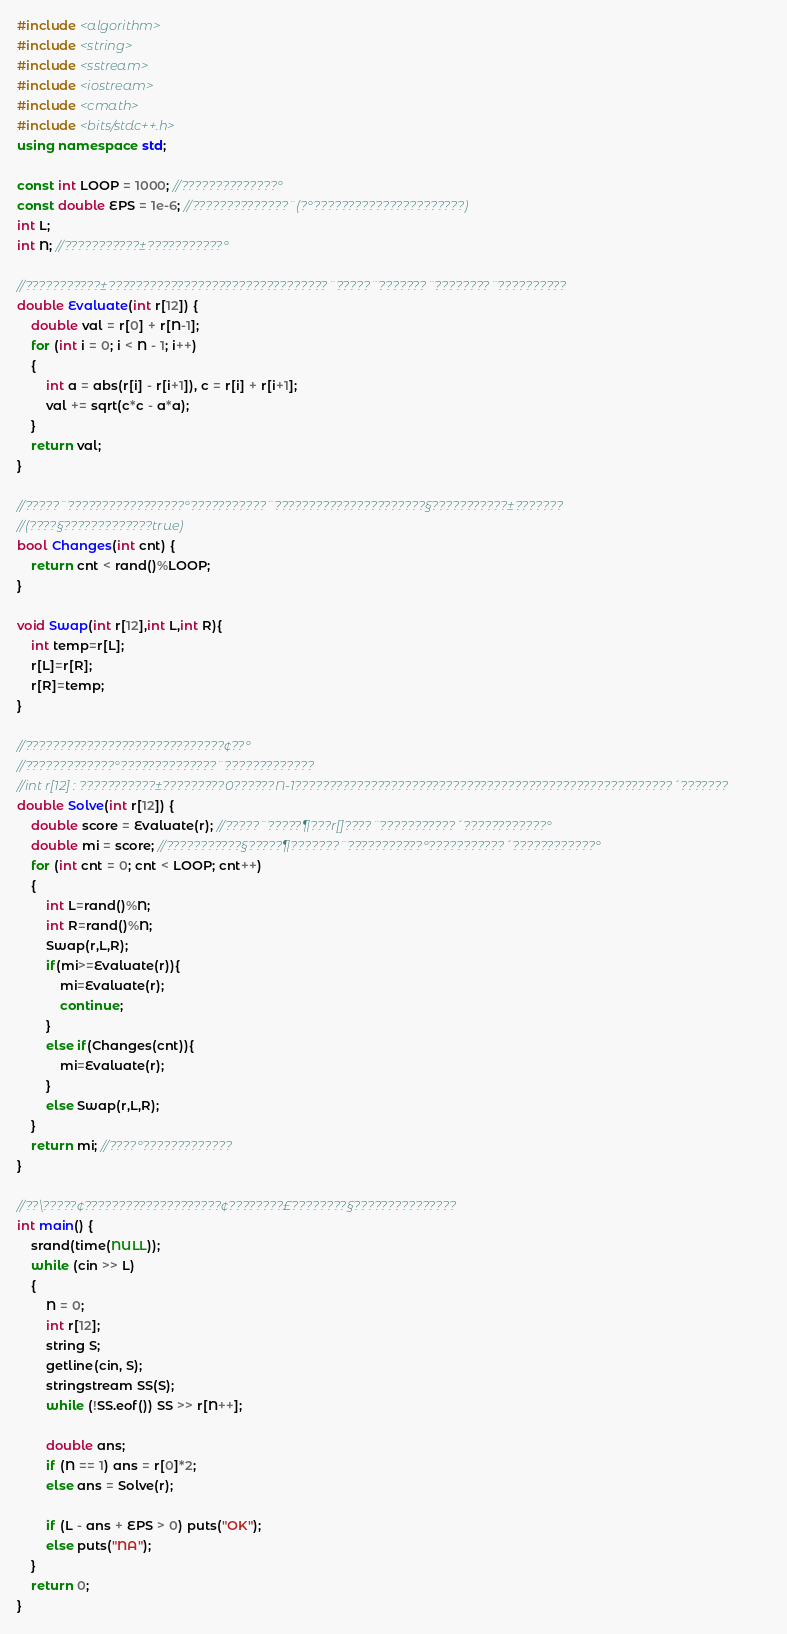<code> <loc_0><loc_0><loc_500><loc_500><_C++_>#include <algorithm>
#include <string>
#include <sstream>
#include <iostream>
#include <cmath>
#include <bits/stdc++.h>
using namespace std;

const int LOOP = 1000; //??????????????°
const double EPS = 1e-6; //??????????????¨(?°??????????????????????)
int L;
int N; //???????????±???????????°

//???????????±????????????????????????????????¨?????¨???????¨????????¨??????????
double Evaluate(int r[12]) {
	double val = r[0] + r[N-1];
	for (int i = 0; i < N - 1; i++)
	{
		int a = abs(r[i] - r[i+1]), c = r[i] + r[i+1];
		val += sqrt(c*c - a*a);
	}
	return val;
}

//?????¨?????????????????°???????????¨??????????????????????§???????????±???????
//(????§?????????????true)
bool Changes(int cnt) {
	return cnt < rand()%LOOP;
}

void Swap(int r[12],int L,int R){
    int temp=r[L];
    r[L]=r[R];
    r[R]=temp;
}

//?????????????????????????????¢??°
//?????????????°??????????????¨?????????????
//int r[12] : ???????????±?????????0??????N-1???????????????????????????????????????????????????????´???????
double Solve(int r[12]) {
	double score = Evaluate(r); //?????¨?????¶???r[]????¨???????????´????????????°
	double mi = score; //???????????§?????¶???????¨???????????°???????????´????????????°
	for (int cnt = 0; cnt < LOOP; cnt++)
	{
	    int L=rand()%N;
	    int R=rand()%N;
	    Swap(r,L,R);
	    if(mi>=Evaluate(r)){
            mi=Evaluate(r);
            continue;
	    }
	    else if(Changes(cnt)){
            mi=Evaluate(r);
	    }
	    else Swap(r,L,R);
	}
	return mi; //????°?????????????
}

//??\?????¢????????????????????¢????????£????????§???????????????
int main() {
    srand(time(NULL));
	while (cin >> L)
	{
		N = 0;
		int r[12];
		string S;
		getline(cin, S);
		stringstream SS(S);
		while (!SS.eof()) SS >> r[N++];

		double ans;
		if (N == 1) ans = r[0]*2;
		else ans = Solve(r);

		if (L - ans + EPS > 0) puts("OK");
		else puts("NA");
	}
	return 0;
}</code> 